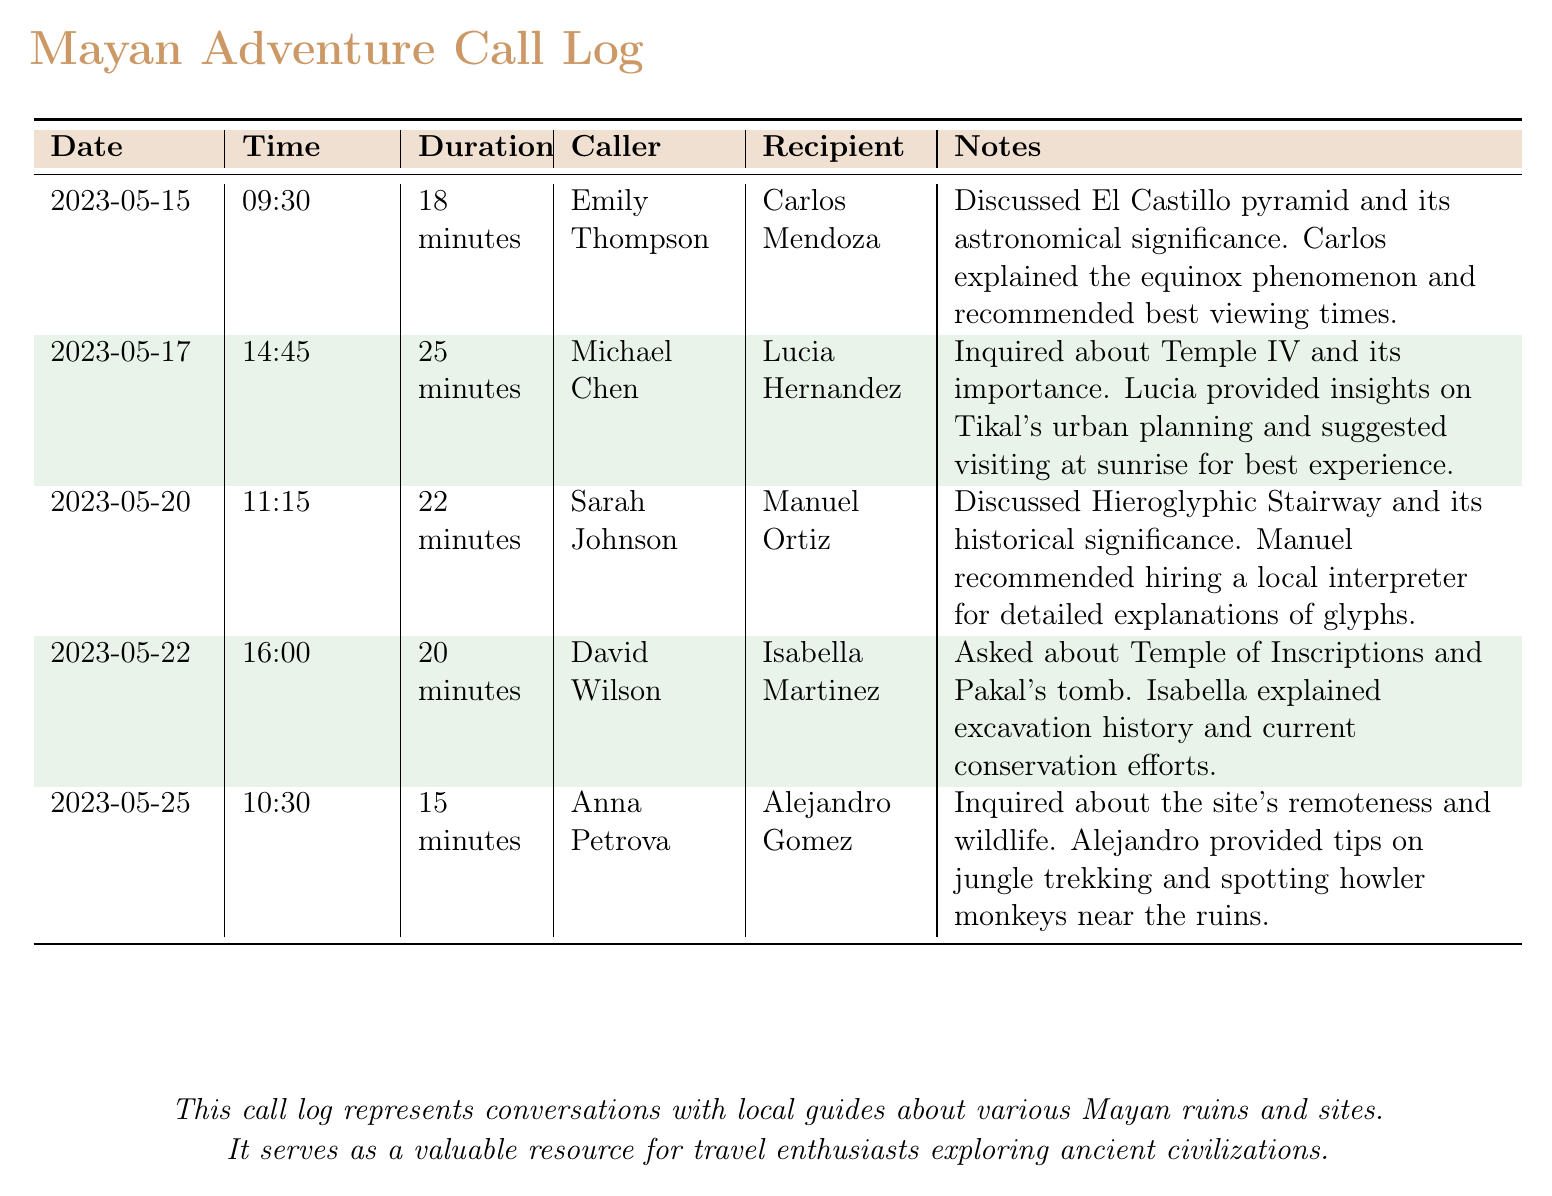What is the date of the call with Carlos Mendoza? The date is directly listed in the call log under the "Date" column for Carlos Mendoza's conversation.
Answer: 2023-05-15 How long was the conversation with Lucia Hernandez? The duration of the call with Lucia Hernandez can be found in the "Duration" column next to her name.
Answer: 25 minutes Who discussed the Hieroglyphic Stairway? The caller who discussed the Hieroglyphic Stairway is mentioned in the "Caller" column associated with that conversation.
Answer: Sarah Johnson What was recommended by Alejandro Gomez? Alejandro Gomez's recommendation is noted in the "Notes" section of his call log entry.
Answer: Jungle trekking On which date did David Wilson speak with Isabella Martinez? The specific date of the call with Isabella Martinez is shown in the "Date" column next to her name.
Answer: 2023-05-22 What phenomenon was explained by Carlos? The specific phenomenon discussed can be found in the "Notes" section of Carlos's conversation entry.
Answer: Equinox phenomenon How many conversations are listed in the document? The total number of entries can be easily counted from the table presented in the document.
Answer: 5 What time did Anna Petrova's call take place? The time of Anna Petrova's call is listed under the "Time" column for her entry.
Answer: 10:30 What is a common theme of the discussions? The common theme can be inferred from the subject matter of the calls recorded in the "Notes" section.
Answer: Ancient Mayan ruins 